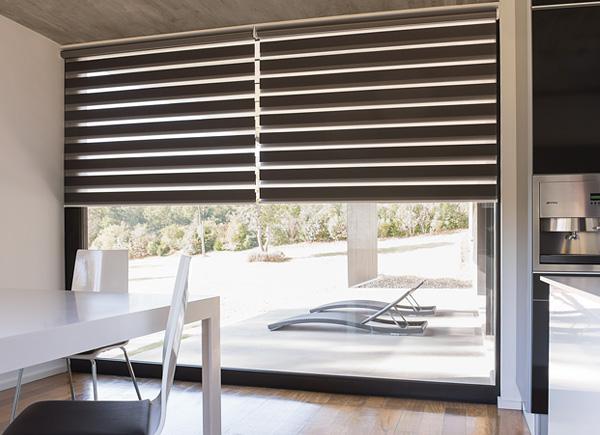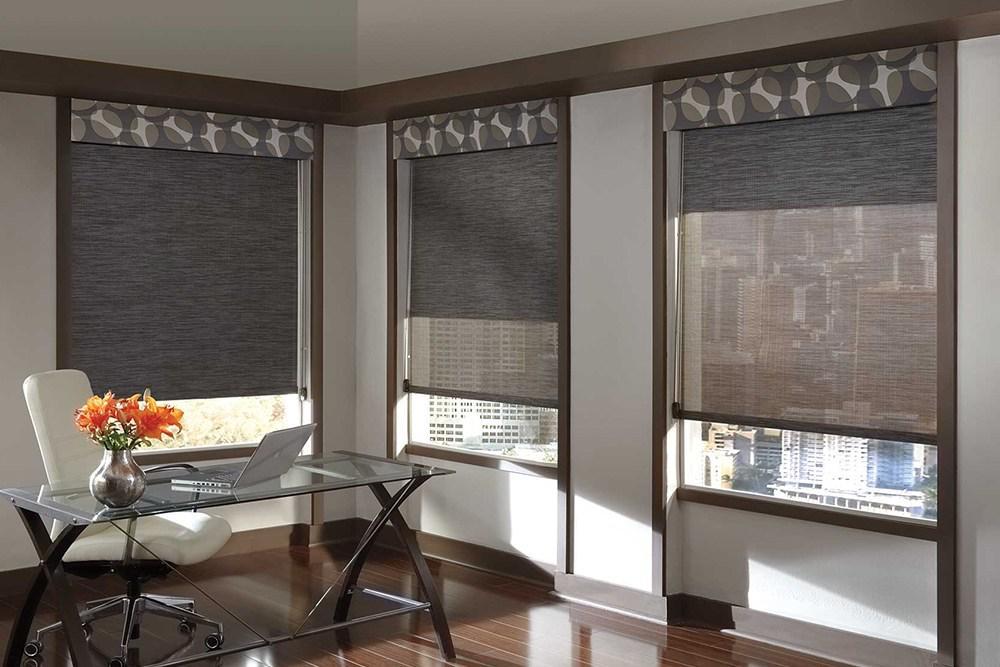The first image is the image on the left, the second image is the image on the right. For the images shown, is this caption "All the shades are partially open." true? Answer yes or no. Yes. The first image is the image on the left, the second image is the image on the right. For the images displayed, is the sentence "There are two windows in the left image." factually correct? Answer yes or no. No. 